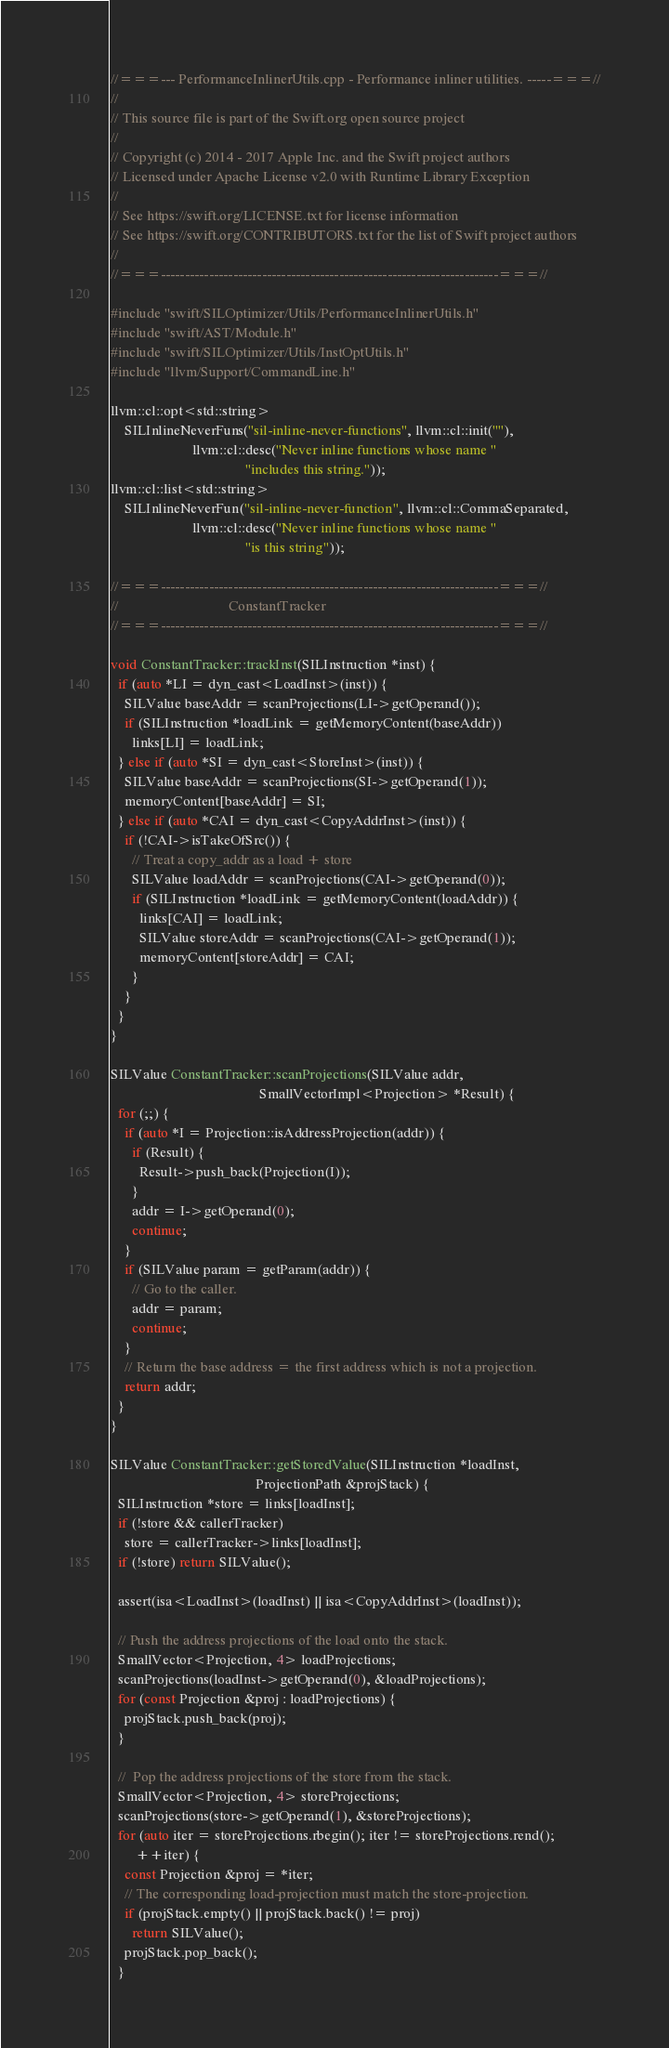<code> <loc_0><loc_0><loc_500><loc_500><_C++_>//===--- PerformanceInlinerUtils.cpp - Performance inliner utilities. -----===//
//
// This source file is part of the Swift.org open source project
//
// Copyright (c) 2014 - 2017 Apple Inc. and the Swift project authors
// Licensed under Apache License v2.0 with Runtime Library Exception
//
// See https://swift.org/LICENSE.txt for license information
// See https://swift.org/CONTRIBUTORS.txt for the list of Swift project authors
//
//===----------------------------------------------------------------------===//

#include "swift/SILOptimizer/Utils/PerformanceInlinerUtils.h"
#include "swift/AST/Module.h"
#include "swift/SILOptimizer/Utils/InstOptUtils.h"
#include "llvm/Support/CommandLine.h"

llvm::cl::opt<std::string>
    SILInlineNeverFuns("sil-inline-never-functions", llvm::cl::init(""),
                       llvm::cl::desc("Never inline functions whose name "
                                      "includes this string."));
llvm::cl::list<std::string>
    SILInlineNeverFun("sil-inline-never-function", llvm::cl::CommaSeparated,
                       llvm::cl::desc("Never inline functions whose name "
                                      "is this string"));

//===----------------------------------------------------------------------===//
//                               ConstantTracker
//===----------------------------------------------------------------------===//

void ConstantTracker::trackInst(SILInstruction *inst) {
  if (auto *LI = dyn_cast<LoadInst>(inst)) {
    SILValue baseAddr = scanProjections(LI->getOperand());
    if (SILInstruction *loadLink = getMemoryContent(baseAddr))
      links[LI] = loadLink;
  } else if (auto *SI = dyn_cast<StoreInst>(inst)) {
    SILValue baseAddr = scanProjections(SI->getOperand(1));
    memoryContent[baseAddr] = SI;
  } else if (auto *CAI = dyn_cast<CopyAddrInst>(inst)) {
    if (!CAI->isTakeOfSrc()) {
      // Treat a copy_addr as a load + store
      SILValue loadAddr = scanProjections(CAI->getOperand(0));
      if (SILInstruction *loadLink = getMemoryContent(loadAddr)) {
        links[CAI] = loadLink;
        SILValue storeAddr = scanProjections(CAI->getOperand(1));
        memoryContent[storeAddr] = CAI;
      }
    }
  }
}

SILValue ConstantTracker::scanProjections(SILValue addr,
                                          SmallVectorImpl<Projection> *Result) {
  for (;;) {
    if (auto *I = Projection::isAddressProjection(addr)) {
      if (Result) {
        Result->push_back(Projection(I));
      }
      addr = I->getOperand(0);
      continue;
    }
    if (SILValue param = getParam(addr)) {
      // Go to the caller.
      addr = param;
      continue;
    }
    // Return the base address = the first address which is not a projection.
    return addr;
  }
}

SILValue ConstantTracker::getStoredValue(SILInstruction *loadInst,
                                         ProjectionPath &projStack) {
  SILInstruction *store = links[loadInst];
  if (!store && callerTracker)
    store = callerTracker->links[loadInst];
  if (!store) return SILValue();

  assert(isa<LoadInst>(loadInst) || isa<CopyAddrInst>(loadInst));

  // Push the address projections of the load onto the stack.
  SmallVector<Projection, 4> loadProjections;
  scanProjections(loadInst->getOperand(0), &loadProjections);
  for (const Projection &proj : loadProjections) {
    projStack.push_back(proj);
  }

  //  Pop the address projections of the store from the stack.
  SmallVector<Projection, 4> storeProjections;
  scanProjections(store->getOperand(1), &storeProjections);
  for (auto iter = storeProjections.rbegin(); iter != storeProjections.rend();
       ++iter) {
    const Projection &proj = *iter;
    // The corresponding load-projection must match the store-projection.
    if (projStack.empty() || projStack.back() != proj)
      return SILValue();
    projStack.pop_back();
  }
</code> 